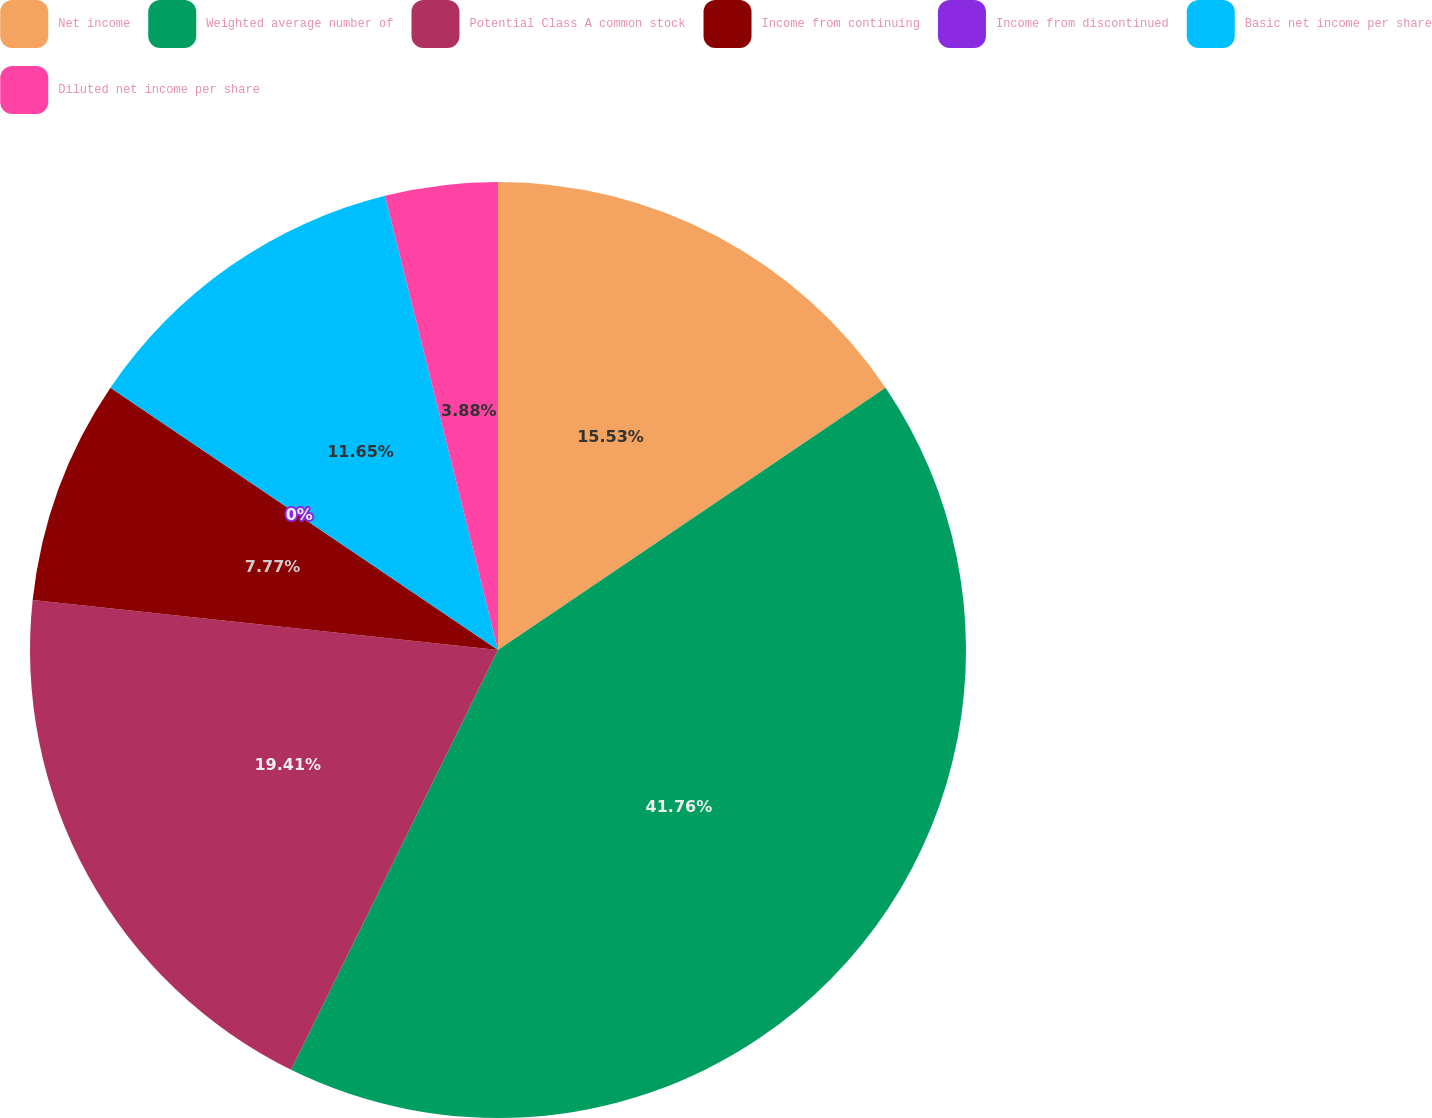Convert chart. <chart><loc_0><loc_0><loc_500><loc_500><pie_chart><fcel>Net income<fcel>Weighted average number of<fcel>Potential Class A common stock<fcel>Income from continuing<fcel>Income from discontinued<fcel>Basic net income per share<fcel>Diluted net income per share<nl><fcel>15.53%<fcel>41.76%<fcel>19.41%<fcel>7.77%<fcel>0.0%<fcel>11.65%<fcel>3.88%<nl></chart> 